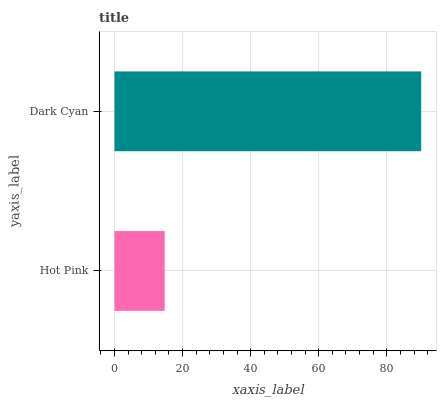Is Hot Pink the minimum?
Answer yes or no. Yes. Is Dark Cyan the maximum?
Answer yes or no. Yes. Is Dark Cyan the minimum?
Answer yes or no. No. Is Dark Cyan greater than Hot Pink?
Answer yes or no. Yes. Is Hot Pink less than Dark Cyan?
Answer yes or no. Yes. Is Hot Pink greater than Dark Cyan?
Answer yes or no. No. Is Dark Cyan less than Hot Pink?
Answer yes or no. No. Is Dark Cyan the high median?
Answer yes or no. Yes. Is Hot Pink the low median?
Answer yes or no. Yes. Is Hot Pink the high median?
Answer yes or no. No. Is Dark Cyan the low median?
Answer yes or no. No. 